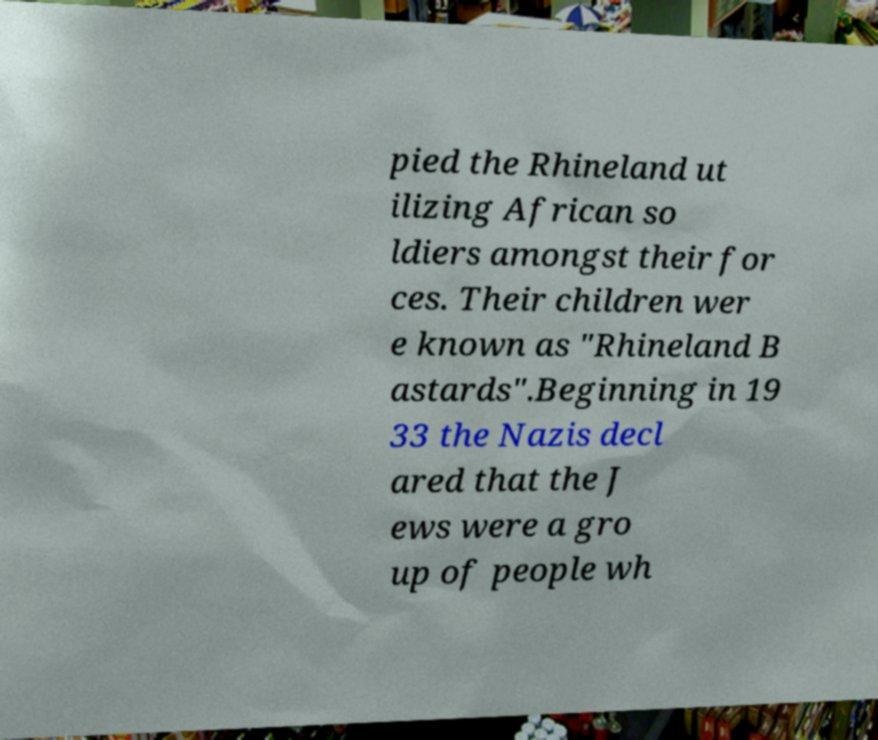Can you read and provide the text displayed in the image?This photo seems to have some interesting text. Can you extract and type it out for me? pied the Rhineland ut ilizing African so ldiers amongst their for ces. Their children wer e known as "Rhineland B astards".Beginning in 19 33 the Nazis decl ared that the J ews were a gro up of people wh 